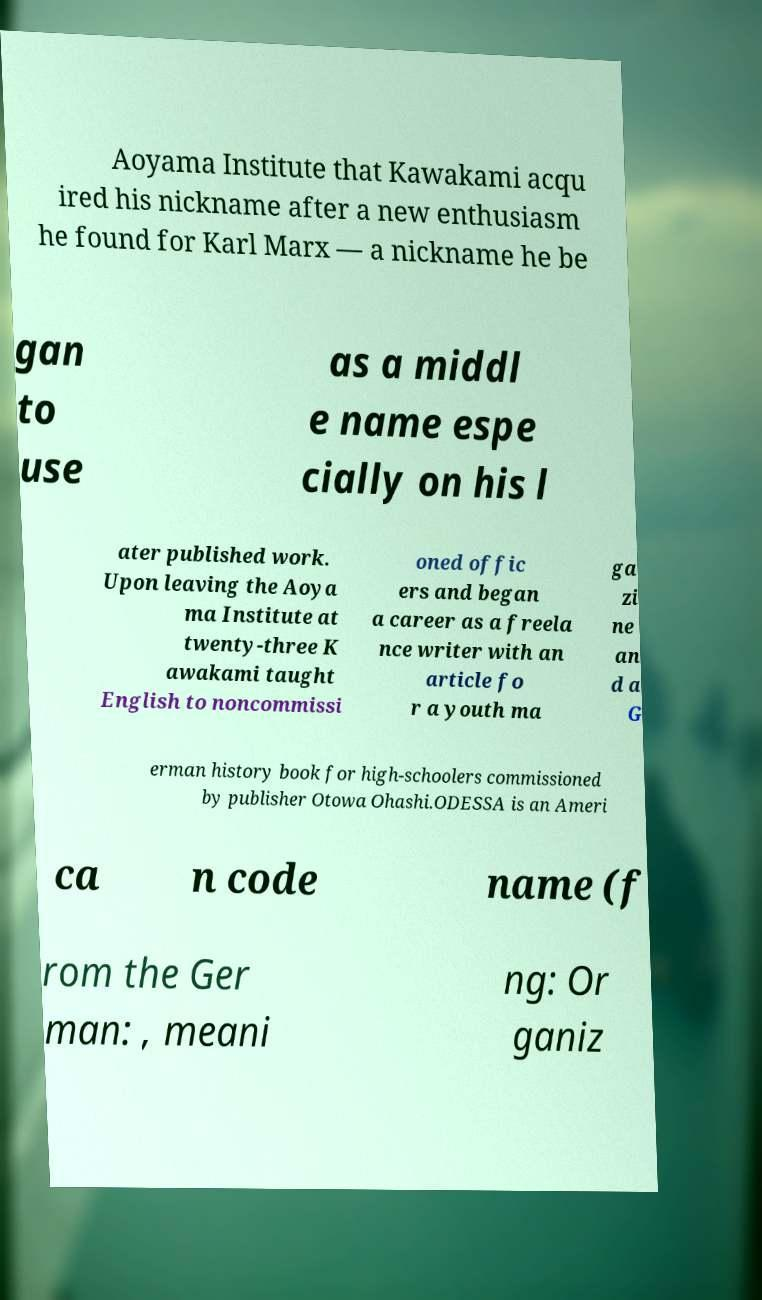Can you read and provide the text displayed in the image?This photo seems to have some interesting text. Can you extract and type it out for me? Aoyama Institute that Kawakami acqu ired his nickname after a new enthusiasm he found for Karl Marx — a nickname he be gan to use as a middl e name espe cially on his l ater published work. Upon leaving the Aoya ma Institute at twenty-three K awakami taught English to noncommissi oned offic ers and began a career as a freela nce writer with an article fo r a youth ma ga zi ne an d a G erman history book for high-schoolers commissioned by publisher Otowa Ohashi.ODESSA is an Ameri ca n code name (f rom the Ger man: , meani ng: Or ganiz 